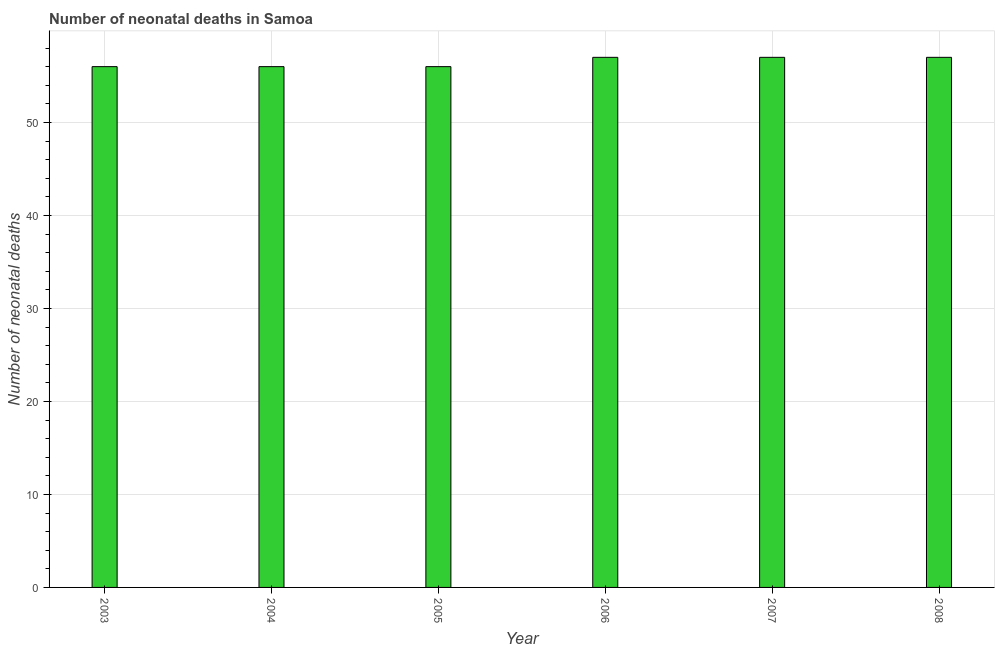Does the graph contain any zero values?
Offer a terse response. No. Does the graph contain grids?
Your answer should be very brief. Yes. What is the title of the graph?
Offer a terse response. Number of neonatal deaths in Samoa. What is the label or title of the Y-axis?
Offer a terse response. Number of neonatal deaths. What is the number of neonatal deaths in 2003?
Offer a terse response. 56. Across all years, what is the minimum number of neonatal deaths?
Give a very brief answer. 56. In which year was the number of neonatal deaths minimum?
Ensure brevity in your answer.  2003. What is the sum of the number of neonatal deaths?
Your answer should be very brief. 339. What is the average number of neonatal deaths per year?
Your answer should be very brief. 56. What is the median number of neonatal deaths?
Give a very brief answer. 56.5. Do a majority of the years between 2003 and 2007 (inclusive) have number of neonatal deaths greater than 46 ?
Make the answer very short. Yes. Is the difference between the number of neonatal deaths in 2004 and 2006 greater than the difference between any two years?
Make the answer very short. Yes. What is the difference between the highest and the lowest number of neonatal deaths?
Make the answer very short. 1. In how many years, is the number of neonatal deaths greater than the average number of neonatal deaths taken over all years?
Provide a short and direct response. 3. How many bars are there?
Provide a short and direct response. 6. Are all the bars in the graph horizontal?
Offer a very short reply. No. Are the values on the major ticks of Y-axis written in scientific E-notation?
Your response must be concise. No. What is the Number of neonatal deaths in 2003?
Offer a very short reply. 56. What is the Number of neonatal deaths in 2004?
Offer a terse response. 56. What is the Number of neonatal deaths in 2006?
Keep it short and to the point. 57. What is the Number of neonatal deaths of 2007?
Ensure brevity in your answer.  57. What is the difference between the Number of neonatal deaths in 2003 and 2004?
Provide a succinct answer. 0. What is the difference between the Number of neonatal deaths in 2003 and 2005?
Ensure brevity in your answer.  0. What is the difference between the Number of neonatal deaths in 2003 and 2006?
Offer a terse response. -1. What is the difference between the Number of neonatal deaths in 2004 and 2005?
Provide a short and direct response. 0. What is the difference between the Number of neonatal deaths in 2004 and 2006?
Your answer should be very brief. -1. What is the difference between the Number of neonatal deaths in 2004 and 2008?
Give a very brief answer. -1. What is the difference between the Number of neonatal deaths in 2005 and 2006?
Make the answer very short. -1. What is the difference between the Number of neonatal deaths in 2005 and 2008?
Provide a short and direct response. -1. What is the difference between the Number of neonatal deaths in 2006 and 2007?
Keep it short and to the point. 0. What is the ratio of the Number of neonatal deaths in 2003 to that in 2004?
Make the answer very short. 1. What is the ratio of the Number of neonatal deaths in 2003 to that in 2005?
Provide a succinct answer. 1. What is the ratio of the Number of neonatal deaths in 2004 to that in 2007?
Give a very brief answer. 0.98. What is the ratio of the Number of neonatal deaths in 2004 to that in 2008?
Provide a succinct answer. 0.98. What is the ratio of the Number of neonatal deaths in 2005 to that in 2007?
Your answer should be very brief. 0.98. What is the ratio of the Number of neonatal deaths in 2007 to that in 2008?
Your response must be concise. 1. 